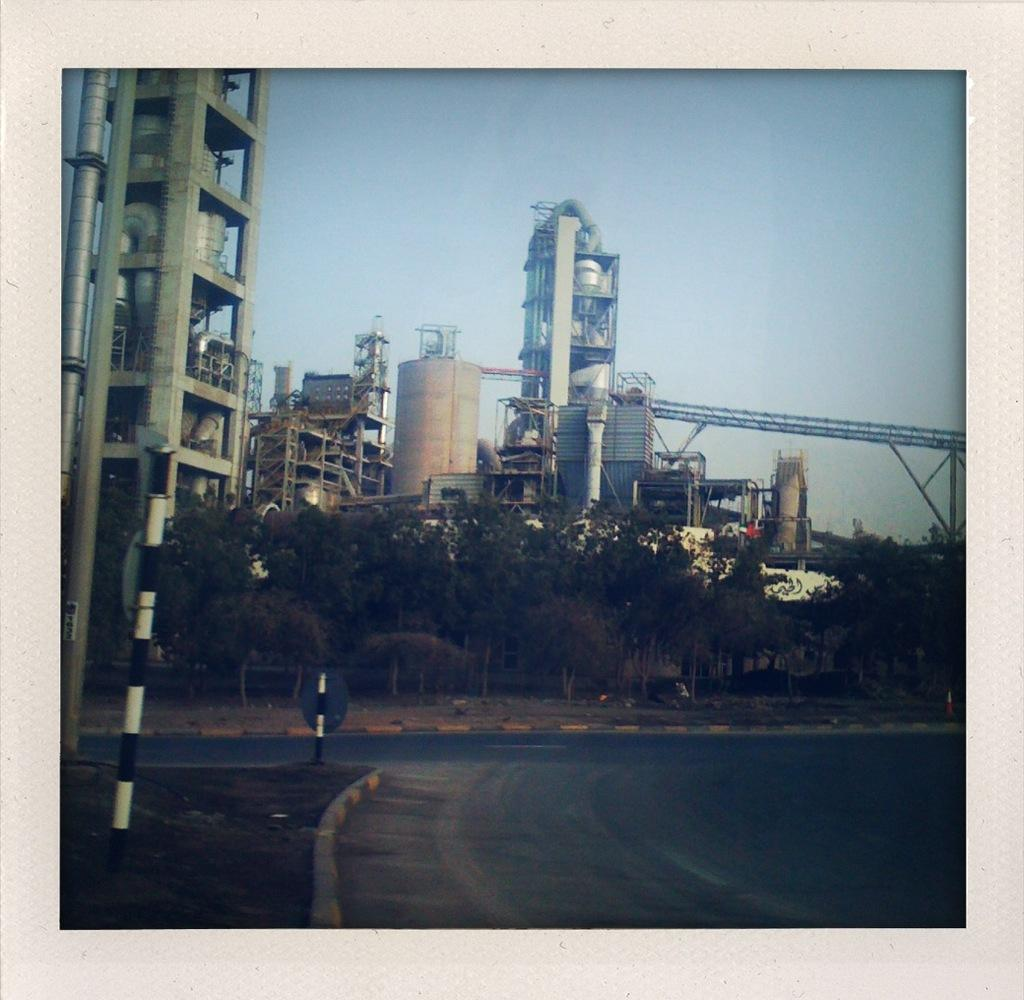What type of vegetation is present in the image? There are trees in the image with green color. What are the colors of the poles in the image? The poles in the image have white and black colors. What can be seen in the background of the image? There are buildings in the background of the image with white colors. What is the color of the sky in the image? The sky in the image has a blue color. What type of breakfast is being served in the image? There is no breakfast present in the image; it features trees, poles, buildings, and a blue sky. Can you hear a song playing in the background of the image? There is no audio or sound present in the image, so it is not possible to determine if a song is playing. 